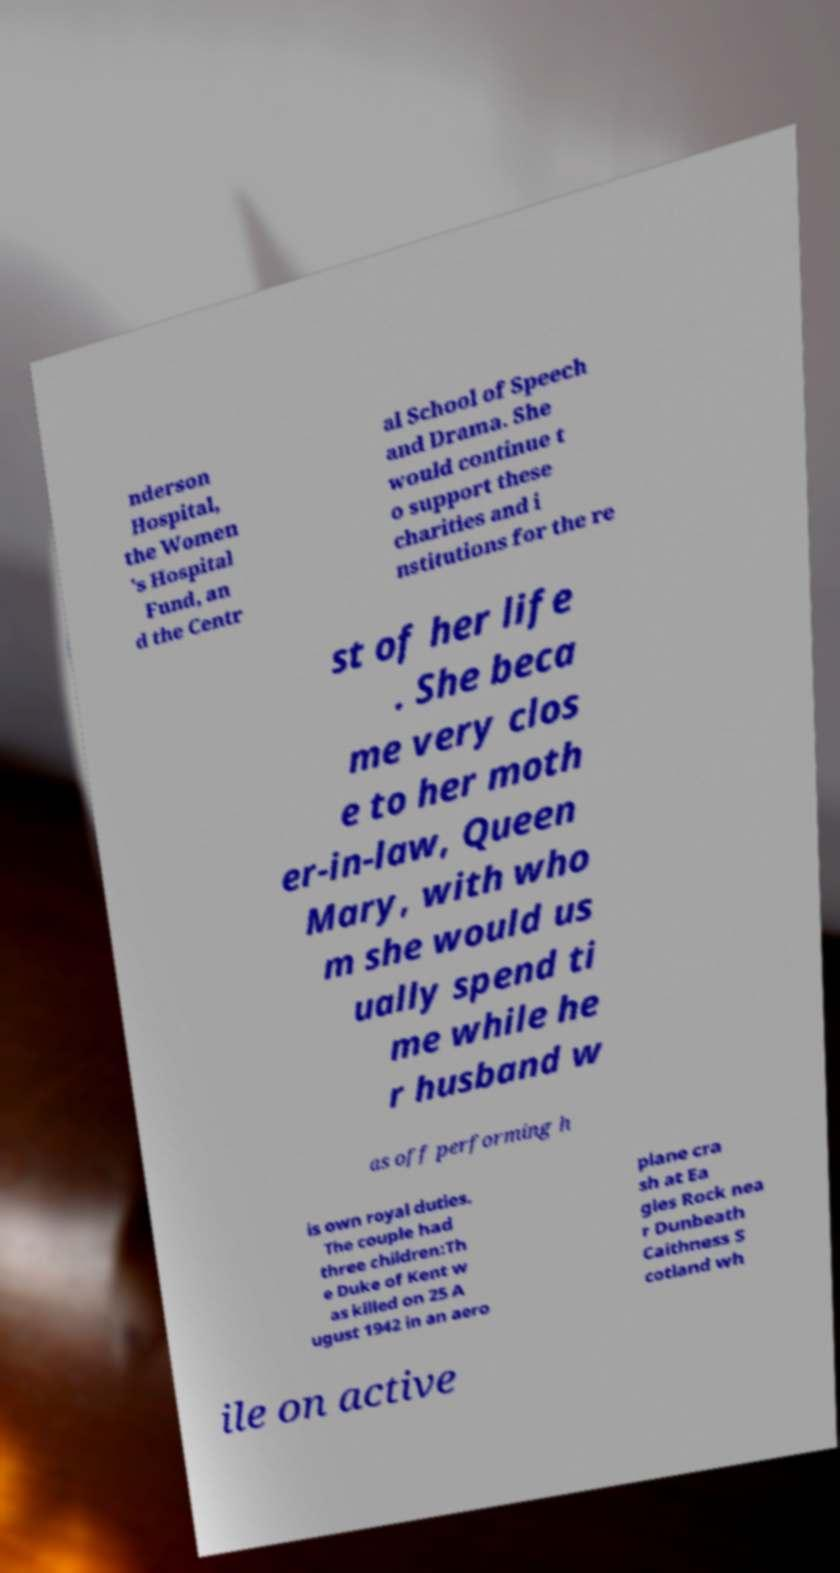Could you assist in decoding the text presented in this image and type it out clearly? nderson Hospital, the Women 's Hospital Fund, an d the Centr al School of Speech and Drama. She would continue t o support these charities and i nstitutions for the re st of her life . She beca me very clos e to her moth er-in-law, Queen Mary, with who m she would us ually spend ti me while he r husband w as off performing h is own royal duties. The couple had three children:Th e Duke of Kent w as killed on 25 A ugust 1942 in an aero plane cra sh at Ea gles Rock nea r Dunbeath Caithness S cotland wh ile on active 